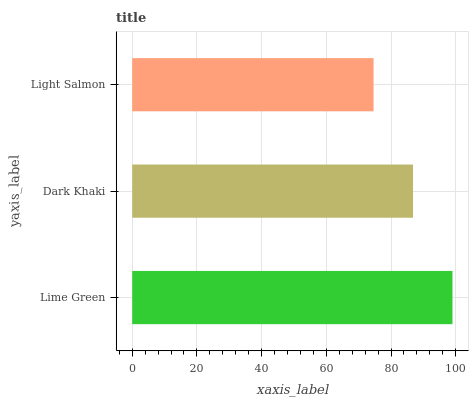Is Light Salmon the minimum?
Answer yes or no. Yes. Is Lime Green the maximum?
Answer yes or no. Yes. Is Dark Khaki the minimum?
Answer yes or no. No. Is Dark Khaki the maximum?
Answer yes or no. No. Is Lime Green greater than Dark Khaki?
Answer yes or no. Yes. Is Dark Khaki less than Lime Green?
Answer yes or no. Yes. Is Dark Khaki greater than Lime Green?
Answer yes or no. No. Is Lime Green less than Dark Khaki?
Answer yes or no. No. Is Dark Khaki the high median?
Answer yes or no. Yes. Is Dark Khaki the low median?
Answer yes or no. Yes. Is Light Salmon the high median?
Answer yes or no. No. Is Lime Green the low median?
Answer yes or no. No. 